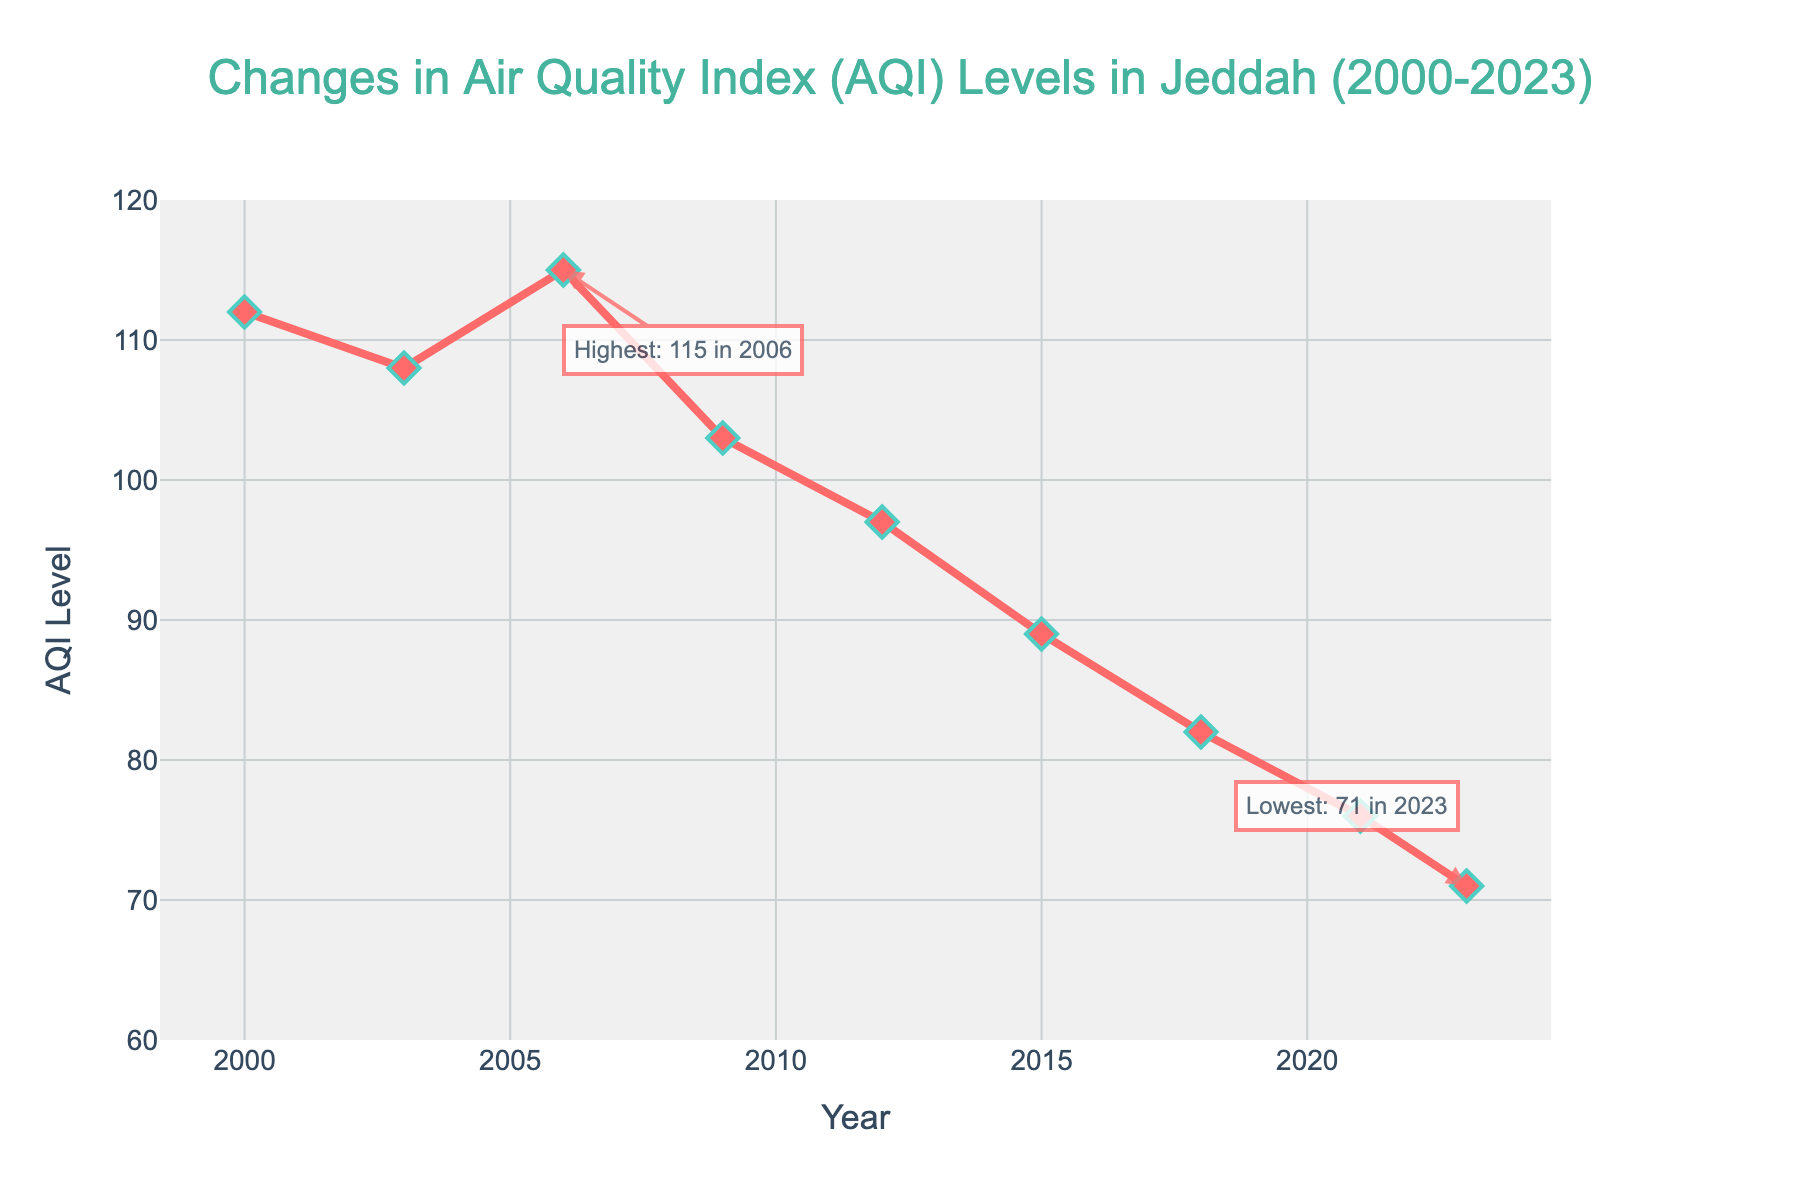What is the overall trend of AQI levels from 2000 to 2023? The overall trend can be observed by examining the line chart which shows the AQI levels decreasing consistently from 2000 to 2023.
Answer: Decreasing What was the AQI level in 2006? By locating the year 2006 on the x-axis and looking at the corresponding y-value, the AQI level is found to be 115.
Answer: 115 Which year recorded the lowest AQI level, and what was the value? The figure highlights the year 2023 as having the lowest AQI level, with an annotation pointing out the value as 71.
Answer: 2023, 71 Compare the AQI levels between 2000 and 2023. Which year had a higher AQI level and by how much? The AQI level in 2000 was 112 and in 2023 it was 71. The difference can be calculated as 112 - 71 = 41, indicating 2000 had a higher AQI level by 41.
Answer: 2000 by 41 What are the highest and lowest AQI levels recorded in the given period, and in which years did they occur? The highest AQI level is 115 in 2006 and the lowest is 71 in 2023, as indicated by the annotations on the figure.
Answer: 115 in 2006, 71 in 2023 By how much did the AQI level decrease from 2000 to 2018? The AQI level in 2000 was 112 and in 2018 it was 82. The decrease can be calculated as 112 - 82 = 30.
Answer: 30 Which period (from the given data points) experienced the most significant drop in AQI levels? The most significant drop happened between 2006 and 2009 where the AQI level decreased from 115 to 103, resulting in a 12-point drop.
Answer: 2006 to 2009 How does the AQI level in 2023 compare to the level in 2009? The AQI level in 2009 was 103 and in 2023 it was 71. Thus, 2023 has a lower AQI level by 103 - 71 = 32.
Answer: 2023 is lower by 32 What is the average AQI level for the given period? Sum the AQI levels: 112 + 108 + 115 + 103 + 97 + 89 + 82 + 76 + 71 = 853. There are 9 data points, so the average is 853/9 ≈ 94.78.
Answer: 94.78 What is the difference in AQI levels between the highest and lowest recorded years? The highest AQI level was 115 in 2006 and the lowest was 71 in 2023. The difference is 115 - 71 = 44.
Answer: 44 